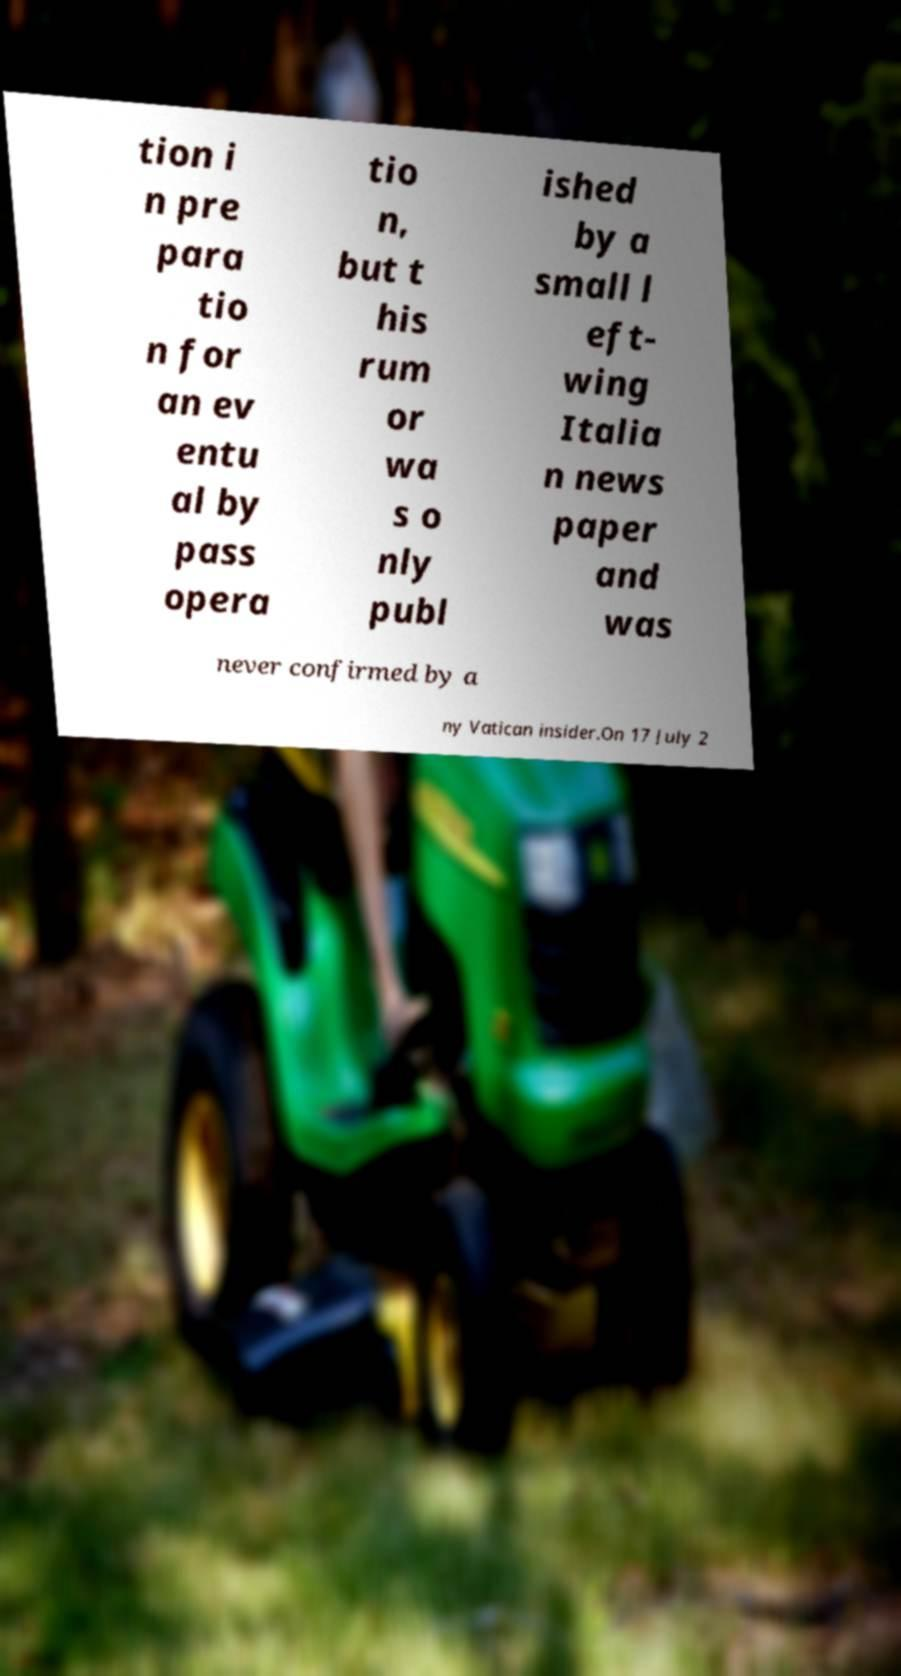For documentation purposes, I need the text within this image transcribed. Could you provide that? tion i n pre para tio n for an ev entu al by pass opera tio n, but t his rum or wa s o nly publ ished by a small l eft- wing Italia n news paper and was never confirmed by a ny Vatican insider.On 17 July 2 